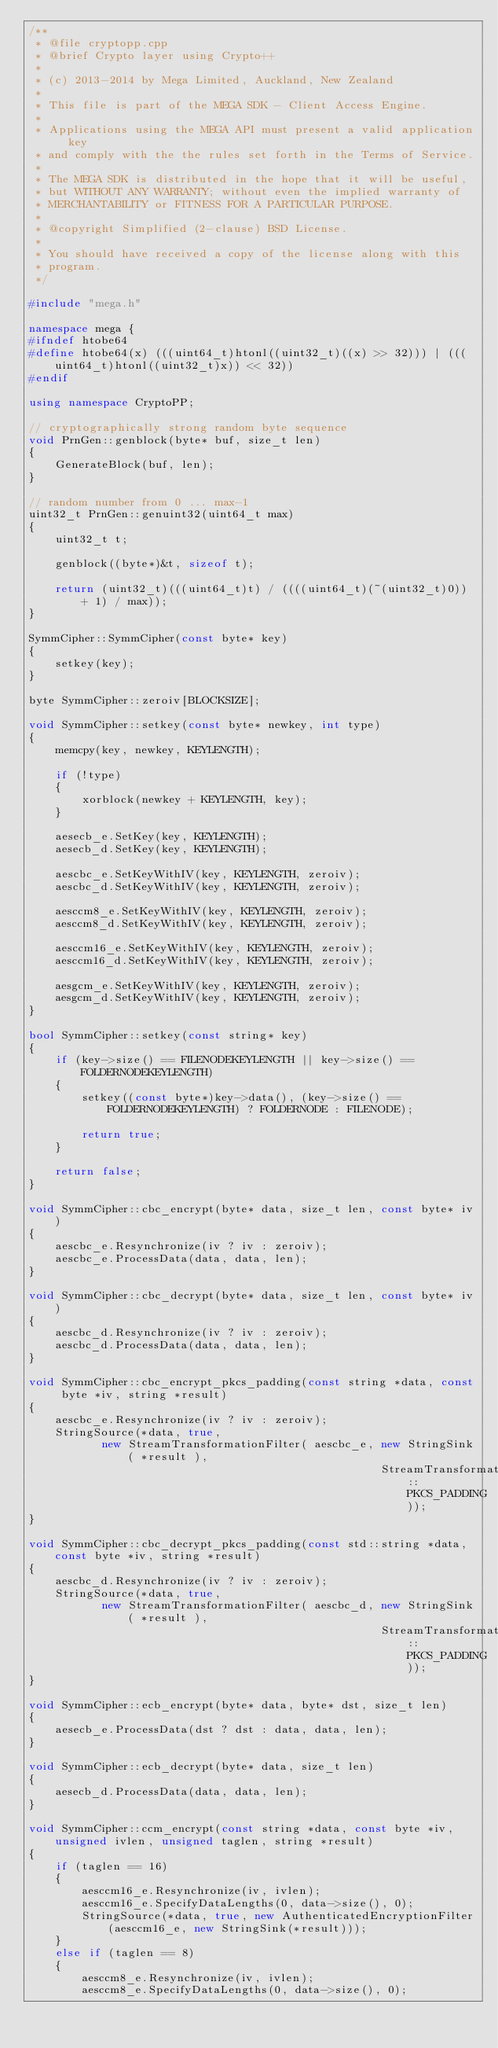<code> <loc_0><loc_0><loc_500><loc_500><_C++_>/**
 * @file cryptopp.cpp
 * @brief Crypto layer using Crypto++
 *
 * (c) 2013-2014 by Mega Limited, Auckland, New Zealand
 *
 * This file is part of the MEGA SDK - Client Access Engine.
 *
 * Applications using the MEGA API must present a valid application key
 * and comply with the the rules set forth in the Terms of Service.
 *
 * The MEGA SDK is distributed in the hope that it will be useful,
 * but WITHOUT ANY WARRANTY; without even the implied warranty of
 * MERCHANTABILITY or FITNESS FOR A PARTICULAR PURPOSE.
 *
 * @copyright Simplified (2-clause) BSD License.
 *
 * You should have received a copy of the license along with this
 * program.
 */

#include "mega.h"

namespace mega {
#ifndef htobe64
#define htobe64(x) (((uint64_t)htonl((uint32_t)((x) >> 32))) | (((uint64_t)htonl((uint32_t)x)) << 32))
#endif

using namespace CryptoPP;

// cryptographically strong random byte sequence
void PrnGen::genblock(byte* buf, size_t len)
{
    GenerateBlock(buf, len);
}

// random number from 0 ... max-1
uint32_t PrnGen::genuint32(uint64_t max)
{
    uint32_t t;

    genblock((byte*)&t, sizeof t);

    return (uint32_t)(((uint64_t)t) / ((((uint64_t)(~(uint32_t)0)) + 1) / max));
}

SymmCipher::SymmCipher(const byte* key)
{
    setkey(key);
}

byte SymmCipher::zeroiv[BLOCKSIZE];

void SymmCipher::setkey(const byte* newkey, int type)
{
    memcpy(key, newkey, KEYLENGTH);

    if (!type)
    {
        xorblock(newkey + KEYLENGTH, key);
    }

    aesecb_e.SetKey(key, KEYLENGTH);
    aesecb_d.SetKey(key, KEYLENGTH);

    aescbc_e.SetKeyWithIV(key, KEYLENGTH, zeroiv);
    aescbc_d.SetKeyWithIV(key, KEYLENGTH, zeroiv);

    aesccm8_e.SetKeyWithIV(key, KEYLENGTH, zeroiv);
    aesccm8_d.SetKeyWithIV(key, KEYLENGTH, zeroiv);

    aesccm16_e.SetKeyWithIV(key, KEYLENGTH, zeroiv);
    aesccm16_d.SetKeyWithIV(key, KEYLENGTH, zeroiv);

    aesgcm_e.SetKeyWithIV(key, KEYLENGTH, zeroiv);
    aesgcm_d.SetKeyWithIV(key, KEYLENGTH, zeroiv);
}

bool SymmCipher::setkey(const string* key)
{
    if (key->size() == FILENODEKEYLENGTH || key->size() == FOLDERNODEKEYLENGTH)
    {
        setkey((const byte*)key->data(), (key->size() == FOLDERNODEKEYLENGTH) ? FOLDERNODE : FILENODE);

        return true;
    }

    return false;
}

void SymmCipher::cbc_encrypt(byte* data, size_t len, const byte* iv)
{
    aescbc_e.Resynchronize(iv ? iv : zeroiv);
    aescbc_e.ProcessData(data, data, len);
}

void SymmCipher::cbc_decrypt(byte* data, size_t len, const byte* iv)
{
    aescbc_d.Resynchronize(iv ? iv : zeroiv);
    aescbc_d.ProcessData(data, data, len);
}

void SymmCipher::cbc_encrypt_pkcs_padding(const string *data, const byte *iv, string *result)
{
    aescbc_e.Resynchronize(iv ? iv : zeroiv);
    StringSource(*data, true,
           new StreamTransformationFilter( aescbc_e, new StringSink( *result ),
                                                     StreamTransformationFilter::PKCS_PADDING));
}

void SymmCipher::cbc_decrypt_pkcs_padding(const std::string *data, const byte *iv, string *result)
{
    aescbc_d.Resynchronize(iv ? iv : zeroiv);
    StringSource(*data, true,
           new StreamTransformationFilter( aescbc_d, new StringSink( *result ),
                                                     StreamTransformationFilter::PKCS_PADDING));
}

void SymmCipher::ecb_encrypt(byte* data, byte* dst, size_t len)
{
    aesecb_e.ProcessData(dst ? dst : data, data, len);
}

void SymmCipher::ecb_decrypt(byte* data, size_t len)
{
    aesecb_d.ProcessData(data, data, len);
}

void SymmCipher::ccm_encrypt(const string *data, const byte *iv, unsigned ivlen, unsigned taglen, string *result)
{
    if (taglen == 16)
    {
        aesccm16_e.Resynchronize(iv, ivlen);
        aesccm16_e.SpecifyDataLengths(0, data->size(), 0);
        StringSource(*data, true, new AuthenticatedEncryptionFilter(aesccm16_e, new StringSink(*result)));
    }
    else if (taglen == 8)
    {
        aesccm8_e.Resynchronize(iv, ivlen);
        aesccm8_e.SpecifyDataLengths(0, data->size(), 0);</code> 